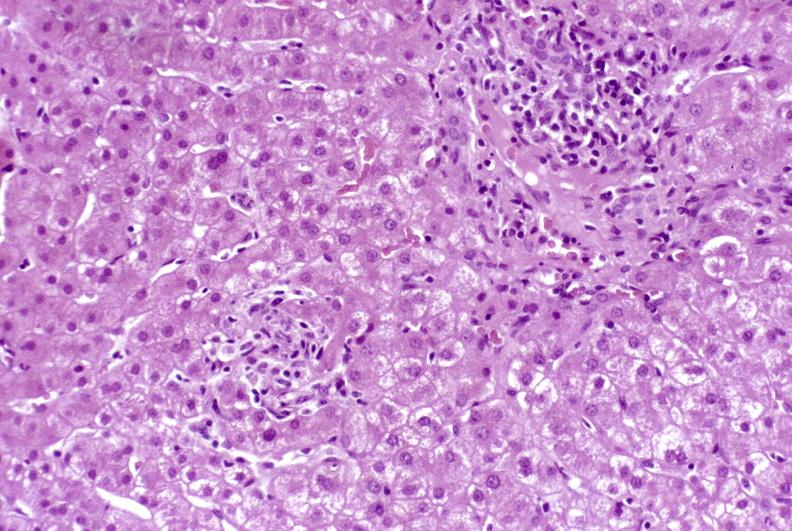s liver present?
Answer the question using a single word or phrase. Yes 